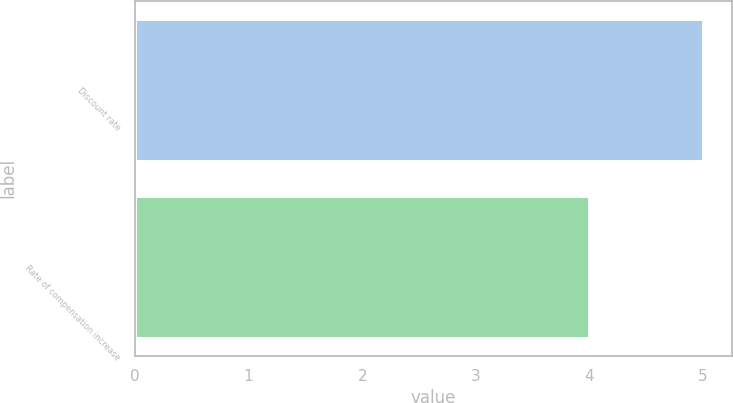Convert chart to OTSL. <chart><loc_0><loc_0><loc_500><loc_500><bar_chart><fcel>Discount rate<fcel>Rate of compensation increase<nl><fcel>5<fcel>4<nl></chart> 